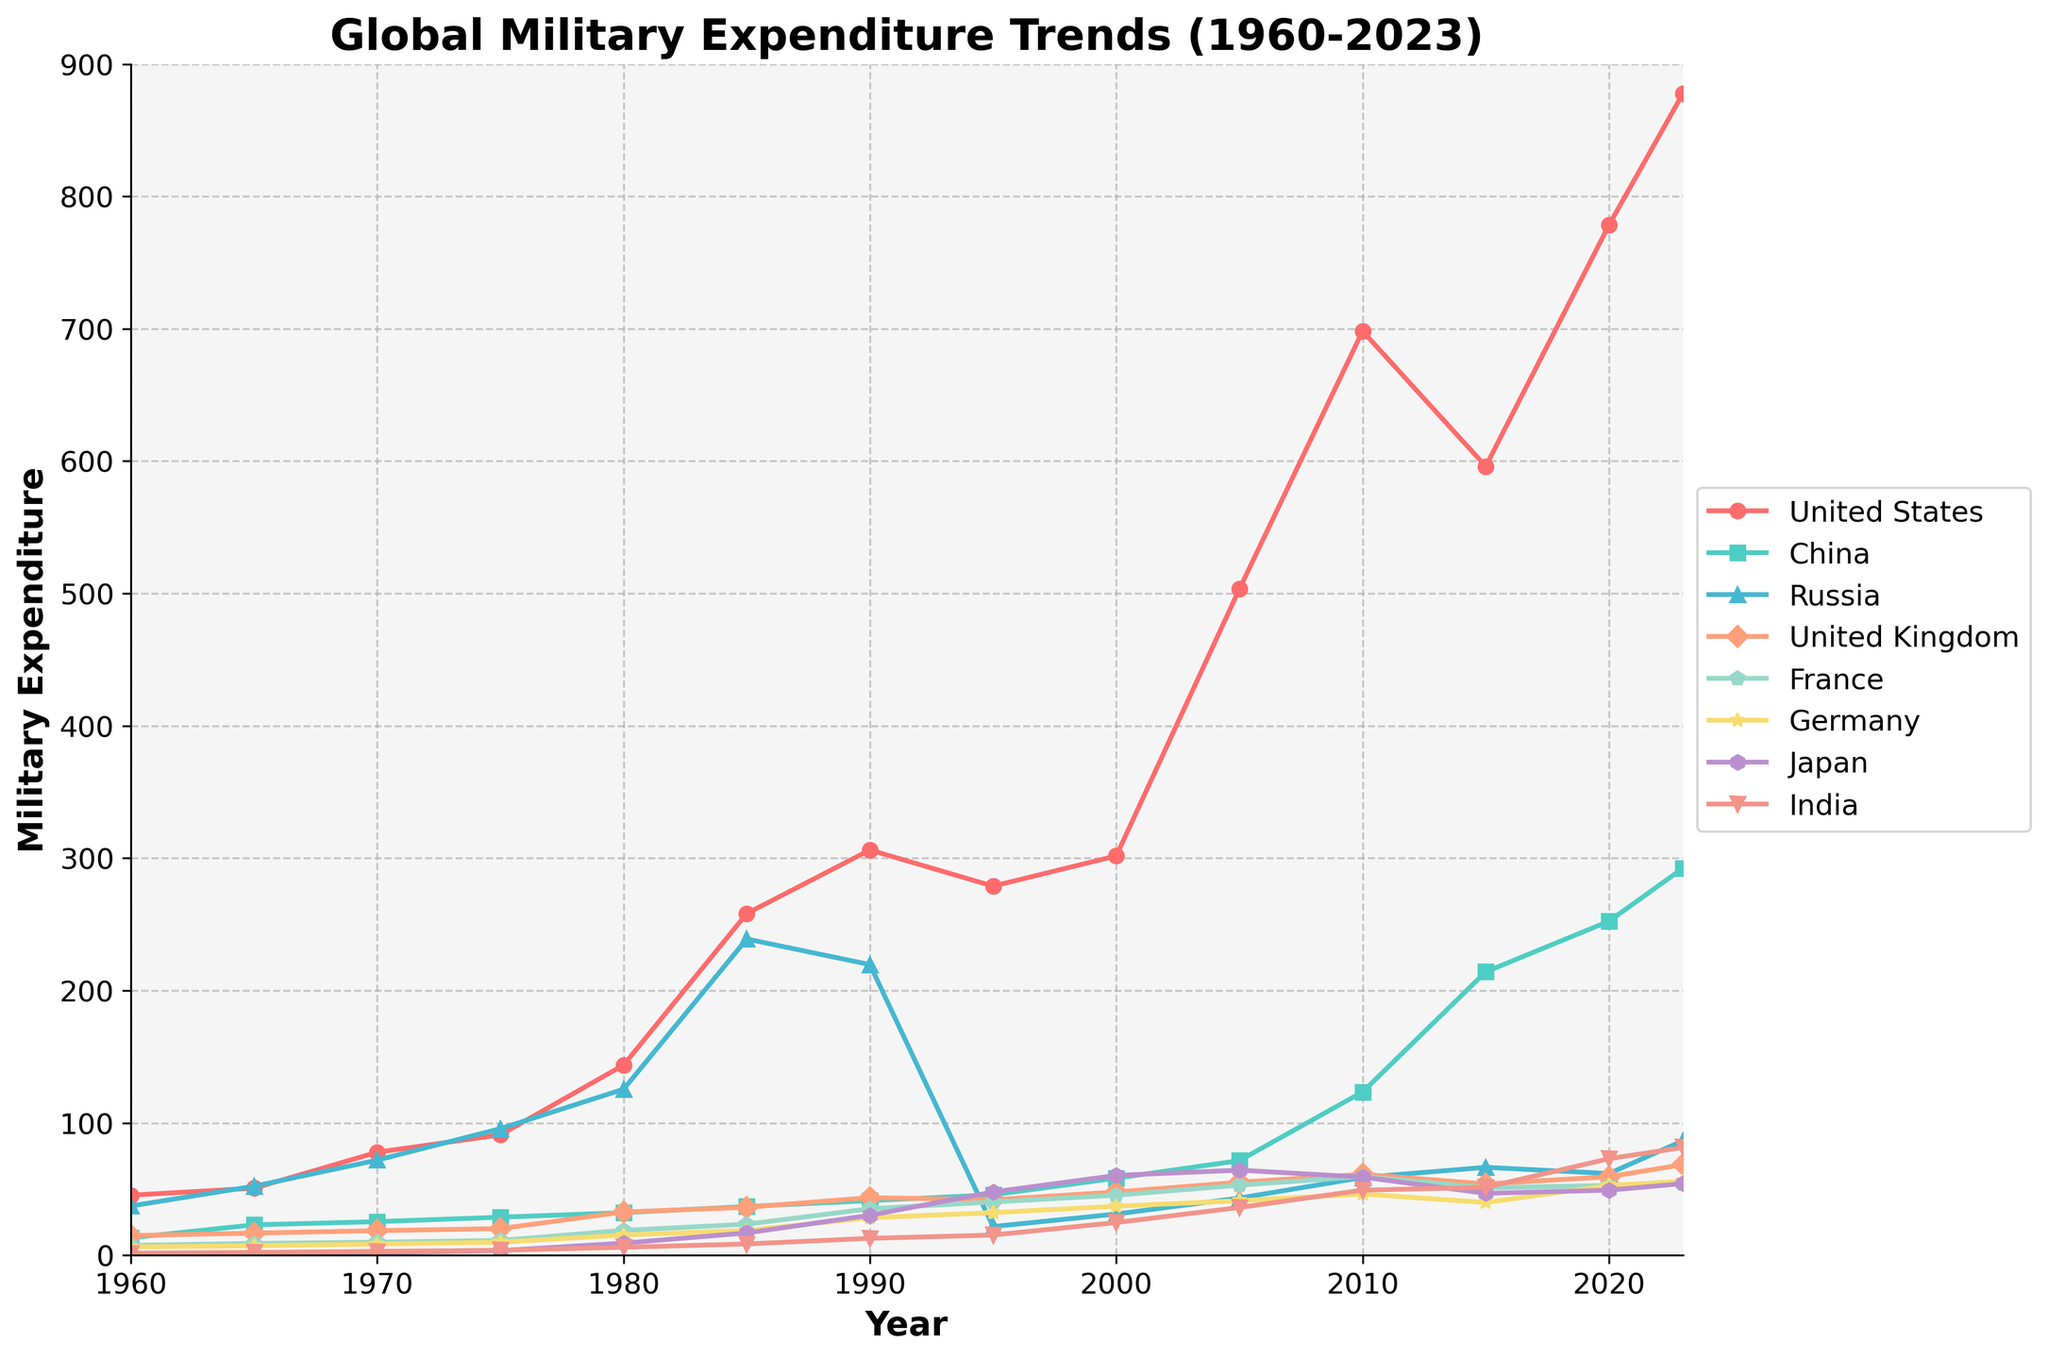What is the trend in military expenditure for the United States from 1960 to 2023? To analyze the trend, look at the trajectory of the line representing the United States from 1960 to 2023. The line shows a general upward trend, with significant increases around 1985 and again after 2000, reaching a peak above 800 in 2023.
Answer: Upward trend Which country had the highest military expenditure in 2023? Observe the lines and their endpoints at the year 2023. The United States' line is the highest, ending near the value of 877.51.
Answer: United States Compare the military expenditure of China and Russia in 1990. Which country spent more? Refer to the lines corresponding to China and Russia at the year 1990. China is at approximately 41.23, while Russia is higher at 219.57.
Answer: Russia How does the military expenditure of India in 2000 compare to its expenditure in 2023? Look at India's line for the years 2000 and 2023. In 2000, the value is about 24.71, and in 2023, it rises to approximately 81.40.
Answer: Increased Calculate the average military expenditure for Germany across the years 1970, 1980, and 1990. Germany's expenditures for the years in question are approximately 8.45, 15.23, and 28.32. The average is calculated as (8.45 + 15.23 + 28.32) / 3 ≈ 17.33.
Answer: 17.33 By how much did France's military expenditure change from 1960 to 2023? France's expenditure in 1960 is approximately 7.45, and in 2023, it is approximately 53.98. The change is calculated as 53.98 - 7.45 = 46.53.
Answer: 46.53 Which country had the lowest military expenditure in 1960 and what was the value? Look at the lines at the year 1960. Japan’s line is the lowest, ending near 0.44.
Answer: Japan, 0.44 Compare the growth in military expenditure of the United Kingdom and Japan from 1960 to 2023. Which country had a higher growth? The United Kingdom's expenditure increases from about 14.82 to 68.48, while Japan's increases from approximately 0.44 to 54.11. Calculate the growth as 68.48 - 14.82 = 53.66 for the UK and 54.11 - 0.44 = 53.67 for Japan.
Answer: Japan Identify the period during which Russia had the highest military expenditure. Observe the line representing Russia and identify the peak value which occurs around 1985.
Answer: 1985 Which country's military expenditure surpassed 200 for the first time after 2010? Among the lines representing different countries, China's line first surpasses 200 around 2015.
Answer: China 